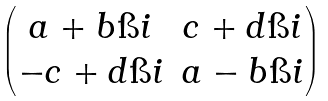Convert formula to latex. <formula><loc_0><loc_0><loc_500><loc_500>\begin{pmatrix} a + b \i i & c + d \i i \\ - c + d \i i & a - b \i i \end{pmatrix}</formula> 